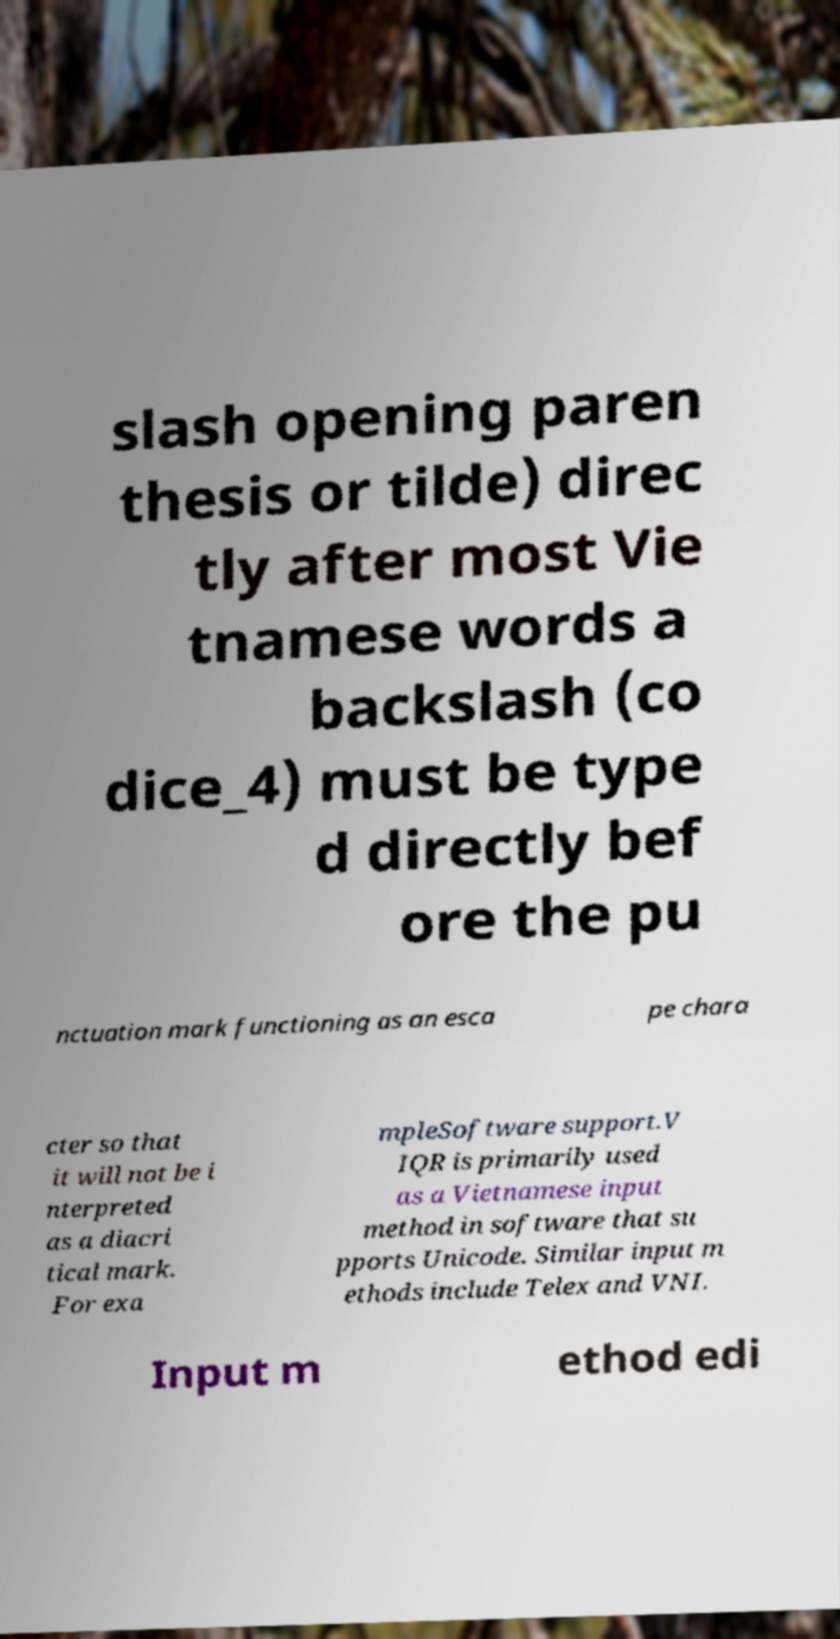Could you assist in decoding the text presented in this image and type it out clearly? slash opening paren thesis or tilde) direc tly after most Vie tnamese words a backslash (co dice_4) must be type d directly bef ore the pu nctuation mark functioning as an esca pe chara cter so that it will not be i nterpreted as a diacri tical mark. For exa mpleSoftware support.V IQR is primarily used as a Vietnamese input method in software that su pports Unicode. Similar input m ethods include Telex and VNI. Input m ethod edi 